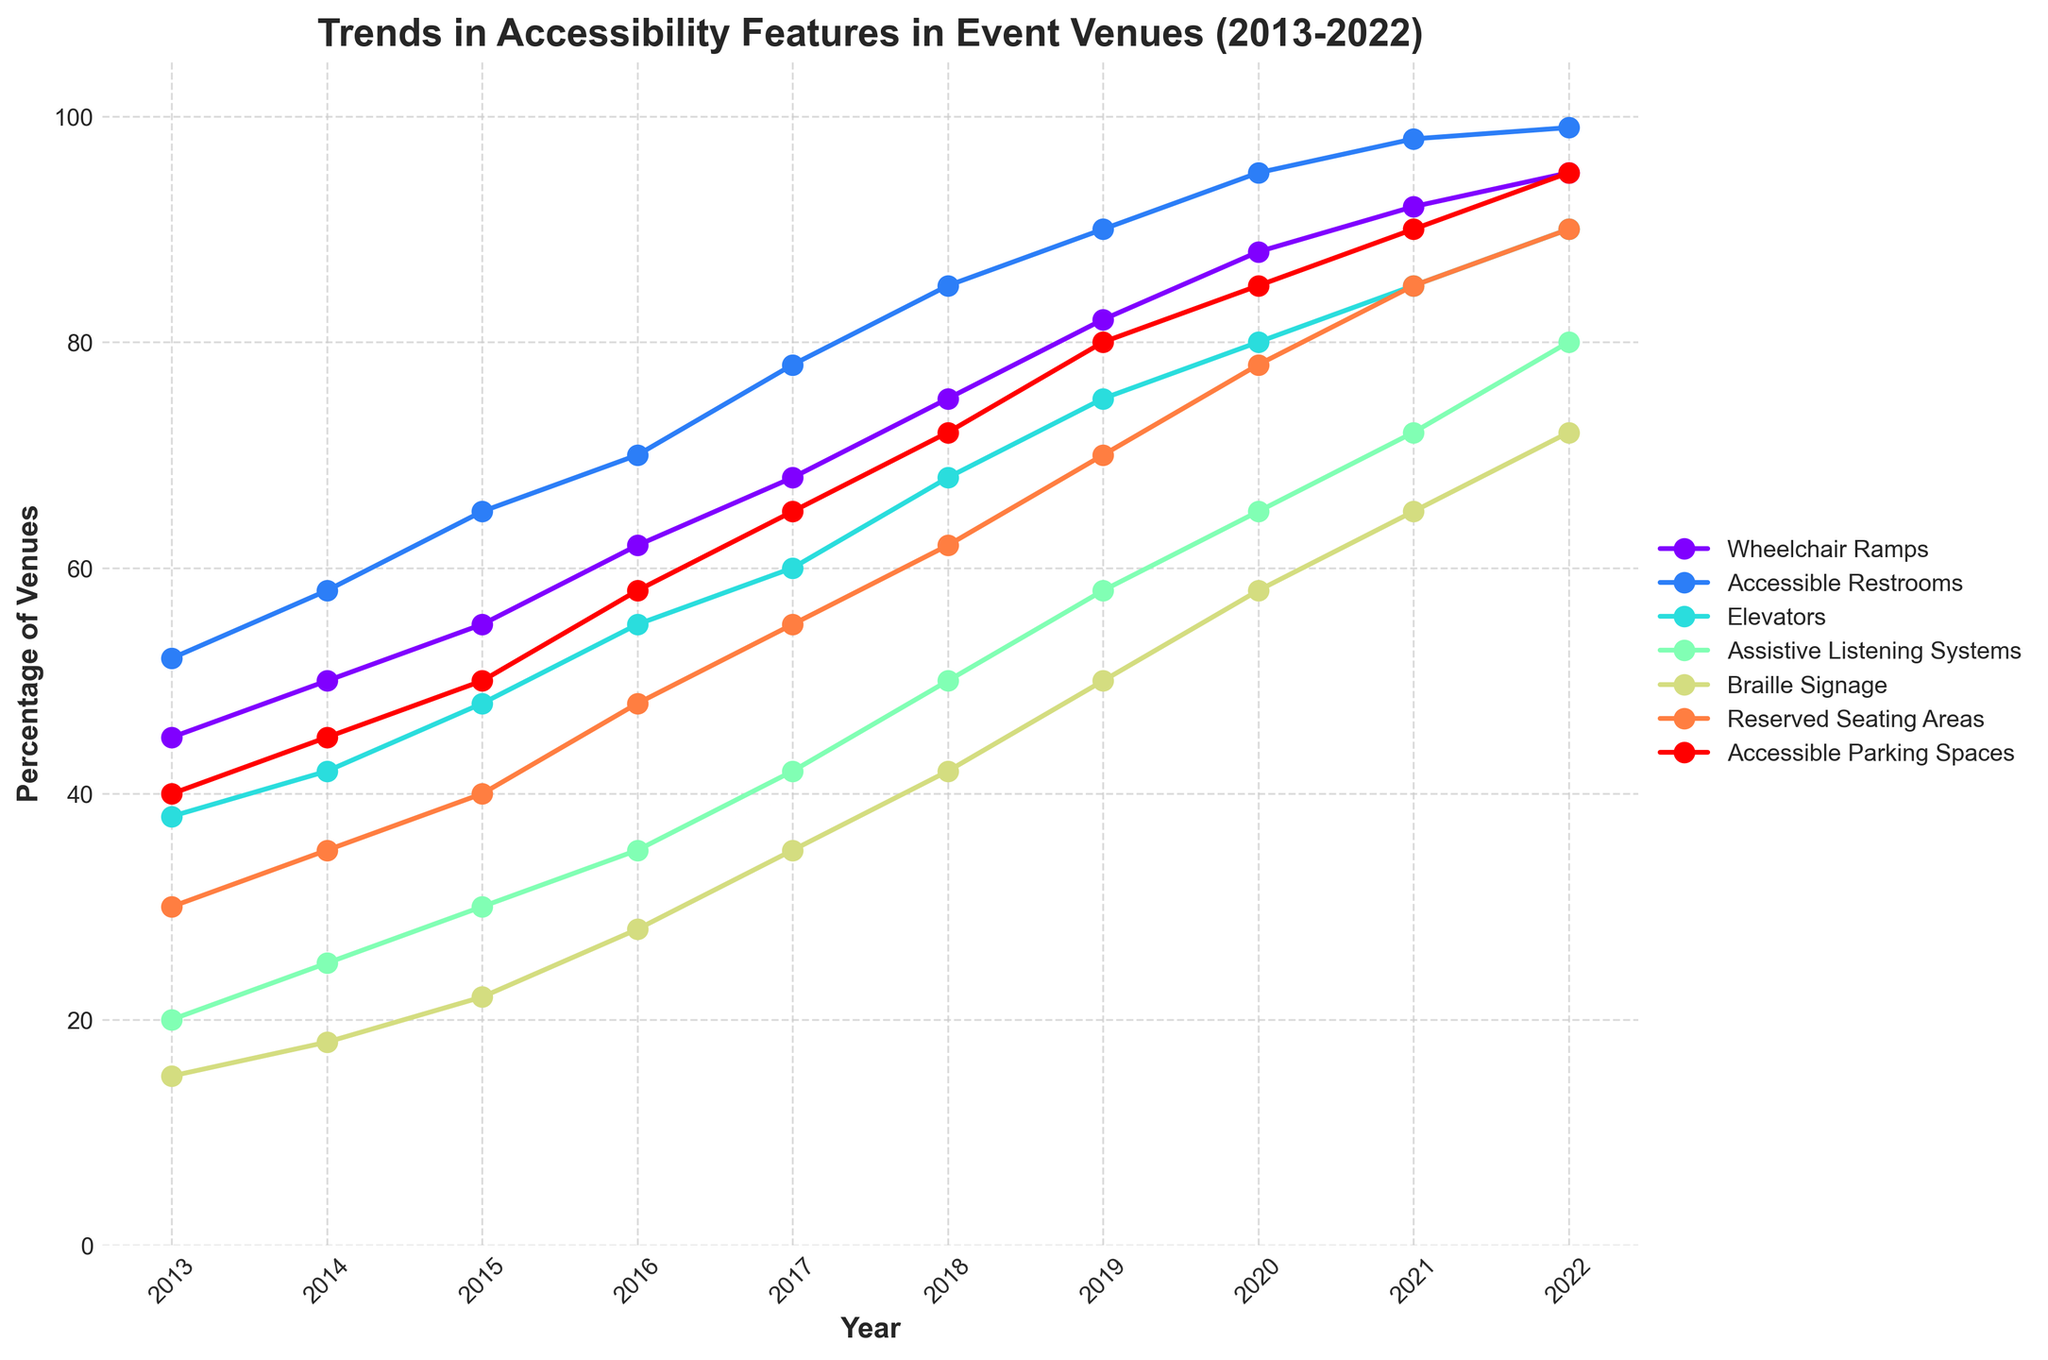Which accessibility feature saw the greatest increase between 2013 and 2022? To determine the greatest increase, subtract the 2013 value from the 2022 value for each feature. Comparing these differences: Wheelchair Ramps (50), Accessible Restrooms (47), Elevators (52), Assistive Listening Systems (60), Braille Signage (57), Reserved Seating Areas (60), Accessible Parking Spaces (55). The largest increase is for Assistive Listening Systems, with a difference of 60.
Answer: Assistive Listening Systems Which year saw the highest number of Accessible Restrooms implemented? Identify the year with the largest value under Accessible Restrooms. By examining the data, 2022 has the highest number of Accessible Restrooms at 99.
Answer: 2022 Between 2015 and 2020, which year had the lowest number of Braille Signage implemented? Compare the number of Braille Signages for the years 2015 to 2020. The numbers are 22, 28, 35, 42, 50, and 58 respectively. Thus, 2015 has the lowest number of Braille Signages at 22.
Answer: 2015 How many features had more than 90 implementations in 2022? Count the number of features with values greater than 90 in 2022. The features are Accessible Restrooms (99), Elevators (90), Assistive Listening Systems (80), Braille Signage (72), Reserved Seating Areas (90), and Accessible Parking Spaces (95). Three features exceed 90 implementations, which are Accessible Restrooms, Reserved Seating Areas, and Accessible Parking Spaces.
Answer: 3 What is the average number of Wheelchair Ramps in 2017 and 2019? Sum the numbers of Wheelchair Ramps in 2017 (68) and 2019 (82), then divide by 2: (68 + 82) / 2 = 150 / 2 = 75.
Answer: 75 Which accessibility feature shows a consistent increase every year? Check each accessibility feature to identify if they have year-on-year increments without any drops. Wheelchair Ramps, Accessible Restrooms, Elevators, Assistive Listening Systems, Braille Signage, Reserved Seating Areas, and Accessible Parking Spaces all consistently increase each year. All seven features show consistent annual increases.
Answer: All seven features What was the total combined number of Accessible Parking Spaces and Assistive Listening Systems in 2020? Add the numbers of Accessible Parking Spaces (85) and Assistive Listening Systems (65) for the year 2020: 85 + 65 = 150.
Answer: 150 Which accessible feature saw the smallest increase from 2014 to 2016? Calculate the increase for each feature from 2014 to 2016. The increases are: Wheelchair Ramps (62-50 = 12), Accessible Restrooms (70-58 = 12), Elevators (55-42 = 13), Assistive Listening Systems (35-25 = 10), Braille Signage (28-18 = 10), Reserved Seating Areas (48-35 = 13), and Accessible Parking Spaces (58-45 = 13). The smallest increase is for Assistive Listening Systems and Braille Signage, both with an increase of 10.
Answer: Assistive Listening Systems, Braille Signage Between 2018 and 2021, which feature saw the steepest increase in implementation? Calculate the increase for each feature from 2018 to 2021. The increases are: Wheelchair Ramps (92-75 = 17), Accessible Restrooms (98-85 = 13), Elevators (85-68 = 17), Assistive Listening Systems (72-50 = 22), Braille Signage (65-42 = 23), Reserved Seating Areas (85-62 = 23), and Accessible Parking Spaces (90-72 = 18). The steepest increases were for Braille Signage and Reserved Seating Areas, both with an increase of 23.
Answer: Braille Signage, Reserved Seating Areas 